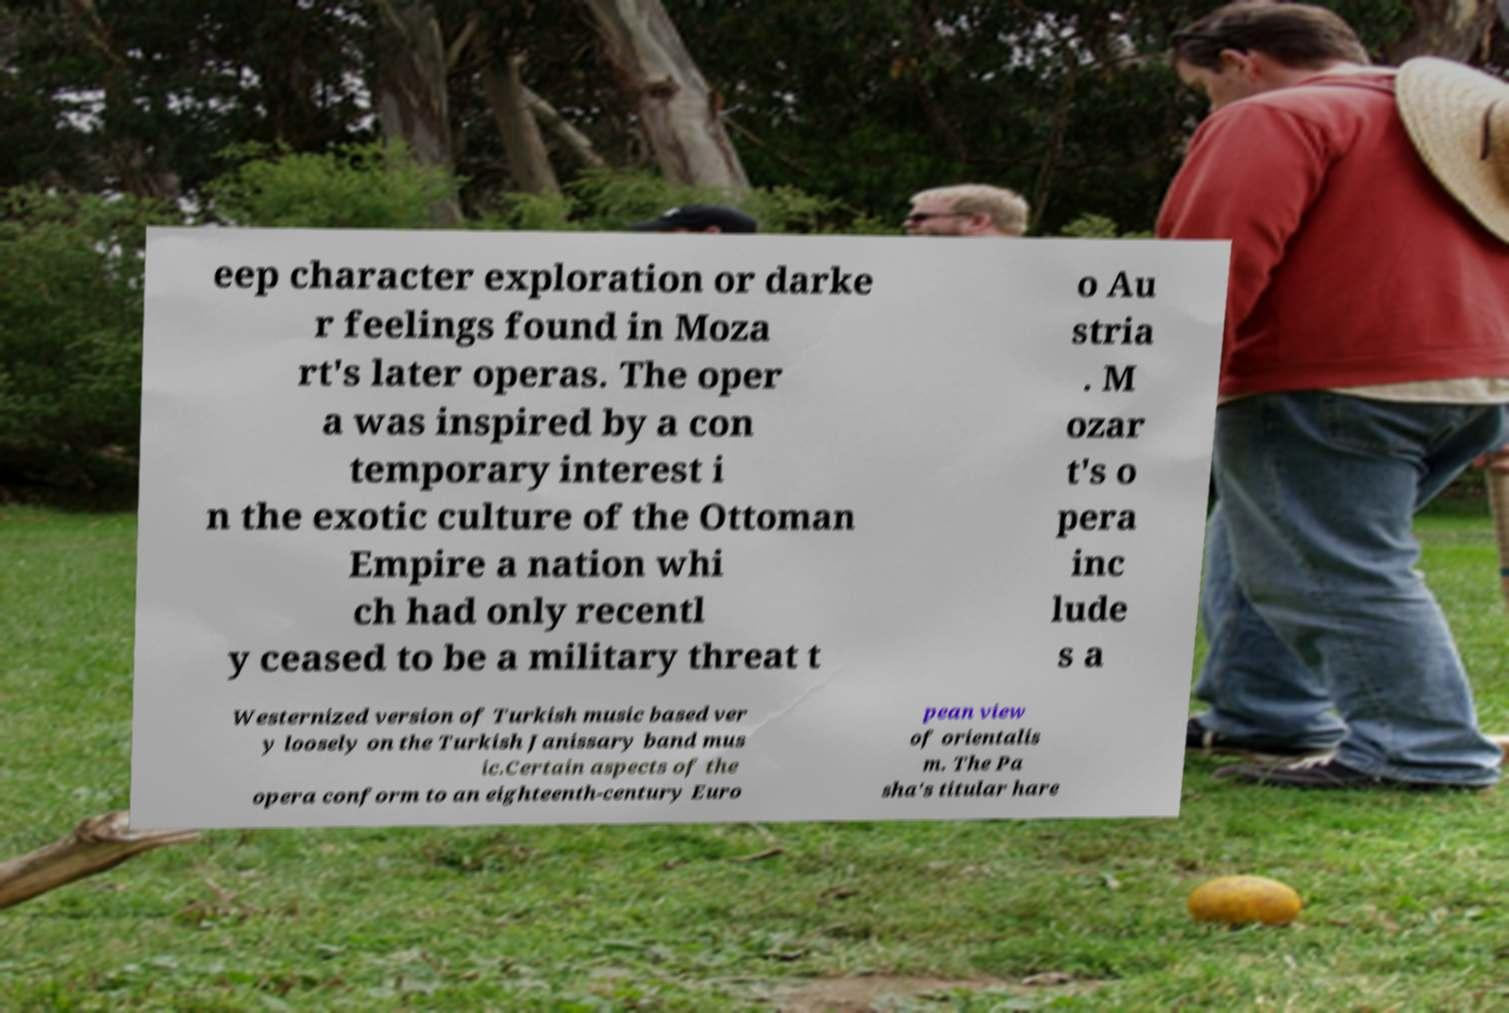Please read and relay the text visible in this image. What does it say? eep character exploration or darke r feelings found in Moza rt's later operas. The oper a was inspired by a con temporary interest i n the exotic culture of the Ottoman Empire a nation whi ch had only recentl y ceased to be a military threat t o Au stria . M ozar t's o pera inc lude s a Westernized version of Turkish music based ver y loosely on the Turkish Janissary band mus ic.Certain aspects of the opera conform to an eighteenth-century Euro pean view of orientalis m. The Pa sha's titular hare 